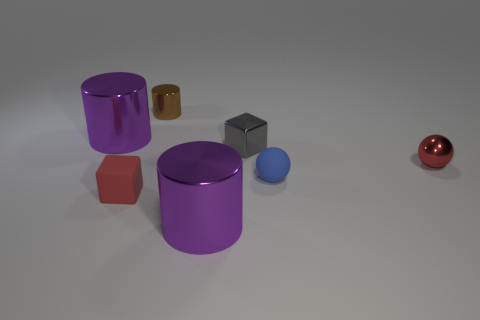Is the number of large purple metallic cylinders on the left side of the small brown cylinder greater than the number of tiny gray objects right of the small gray metallic thing?
Ensure brevity in your answer.  Yes. Do the shiny cube and the red metallic object have the same size?
Give a very brief answer. Yes. There is another tiny object that is the same shape as the gray metal thing; what color is it?
Your answer should be very brief. Red. What number of large metal cylinders are the same color as the tiny metallic cylinder?
Ensure brevity in your answer.  0. Are there more red rubber objects to the right of the red ball than large gray rubber cubes?
Your answer should be compact. No. There is a metallic object in front of the tiny cube left of the gray metal thing; what is its color?
Provide a succinct answer. Purple. How many things are metallic objects that are on the right side of the small blue matte object or small red things that are to the right of the tiny metallic cylinder?
Offer a terse response. 1. The tiny metal cylinder is what color?
Provide a succinct answer. Brown. What number of small brown objects have the same material as the gray block?
Your answer should be very brief. 1. Are there more big metallic cylinders than small blue things?
Offer a very short reply. Yes. 